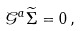<formula> <loc_0><loc_0><loc_500><loc_500>\mathcal { G } ^ { a } \widetilde { \Sigma } = 0 \, ,</formula> 